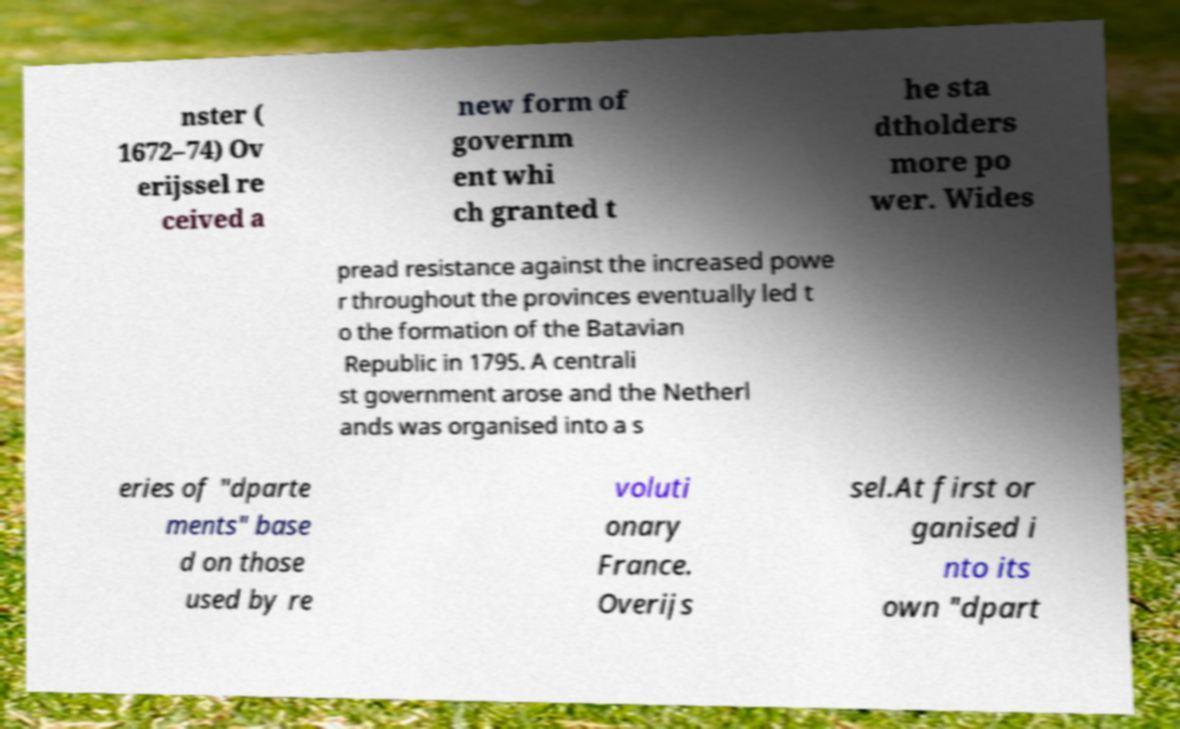Please identify and transcribe the text found in this image. nster ( 1672–74) Ov erijssel re ceived a new form of governm ent whi ch granted t he sta dtholders more po wer. Wides pread resistance against the increased powe r throughout the provinces eventually led t o the formation of the Batavian Republic in 1795. A centrali st government arose and the Netherl ands was organised into a s eries of "dparte ments" base d on those used by re voluti onary France. Overijs sel.At first or ganised i nto its own "dpart 